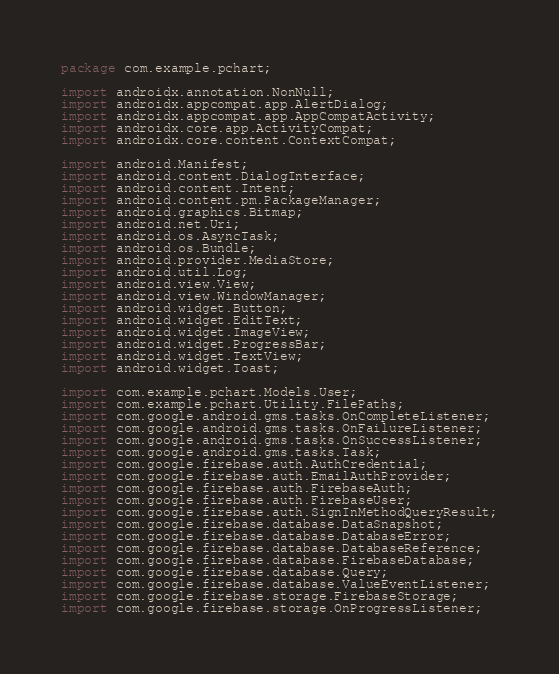<code> <loc_0><loc_0><loc_500><loc_500><_Java_>package com.example.pchart;

import androidx.annotation.NonNull;
import androidx.appcompat.app.AlertDialog;
import androidx.appcompat.app.AppCompatActivity;
import androidx.core.app.ActivityCompat;
import androidx.core.content.ContextCompat;

import android.Manifest;
import android.content.DialogInterface;
import android.content.Intent;
import android.content.pm.PackageManager;
import android.graphics.Bitmap;
import android.net.Uri;
import android.os.AsyncTask;
import android.os.Bundle;
import android.provider.MediaStore;
import android.util.Log;
import android.view.View;
import android.view.WindowManager;
import android.widget.Button;
import android.widget.EditText;
import android.widget.ImageView;
import android.widget.ProgressBar;
import android.widget.TextView;
import android.widget.Toast;

import com.example.pchart.Models.User;
import com.example.pchart.Utility.FilePaths;
import com.google.android.gms.tasks.OnCompleteListener;
import com.google.android.gms.tasks.OnFailureListener;
import com.google.android.gms.tasks.OnSuccessListener;
import com.google.android.gms.tasks.Task;
import com.google.firebase.auth.AuthCredential;
import com.google.firebase.auth.EmailAuthProvider;
import com.google.firebase.auth.FirebaseAuth;
import com.google.firebase.auth.FirebaseUser;
import com.google.firebase.auth.SignInMethodQueryResult;
import com.google.firebase.database.DataSnapshot;
import com.google.firebase.database.DatabaseError;
import com.google.firebase.database.DatabaseReference;
import com.google.firebase.database.FirebaseDatabase;
import com.google.firebase.database.Query;
import com.google.firebase.database.ValueEventListener;
import com.google.firebase.storage.FirebaseStorage;
import com.google.firebase.storage.OnProgressListener;</code> 